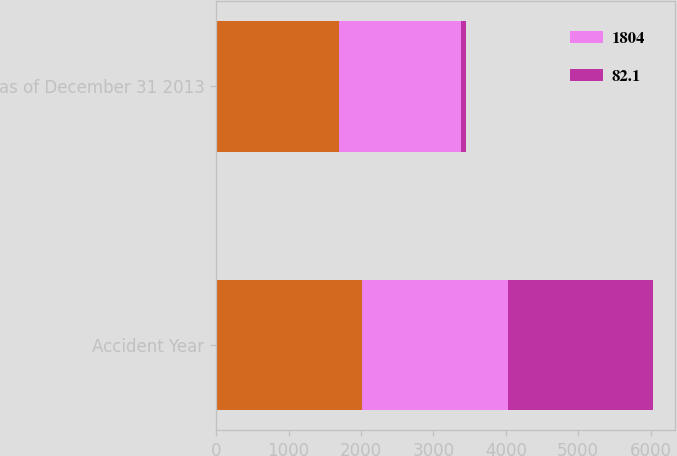<chart> <loc_0><loc_0><loc_500><loc_500><stacked_bar_chart><ecel><fcel>Accident Year<fcel>as of December 31 2013<nl><fcel>nan<fcel>2013<fcel>1691<nl><fcel>1804<fcel>2011<fcel>1685<nl><fcel>82.1<fcel>2011<fcel>76.7<nl></chart> 